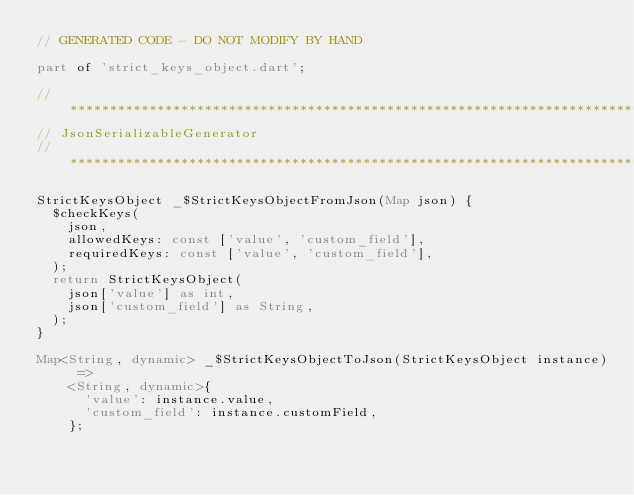Convert code to text. <code><loc_0><loc_0><loc_500><loc_500><_Dart_>// GENERATED CODE - DO NOT MODIFY BY HAND

part of 'strict_keys_object.dart';

// **************************************************************************
// JsonSerializableGenerator
// **************************************************************************

StrictKeysObject _$StrictKeysObjectFromJson(Map json) {
  $checkKeys(
    json,
    allowedKeys: const ['value', 'custom_field'],
    requiredKeys: const ['value', 'custom_field'],
  );
  return StrictKeysObject(
    json['value'] as int,
    json['custom_field'] as String,
  );
}

Map<String, dynamic> _$StrictKeysObjectToJson(StrictKeysObject instance) =>
    <String, dynamic>{
      'value': instance.value,
      'custom_field': instance.customField,
    };
</code> 